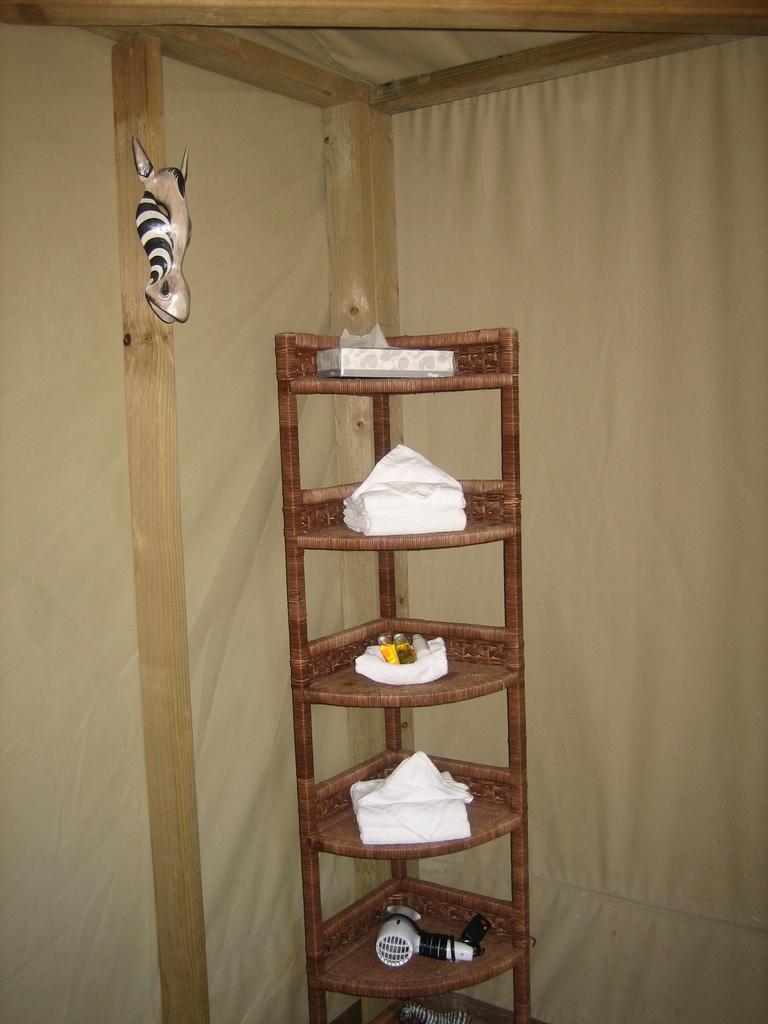Could you give a brief overview of what you see in this image? In this image we can see a box, tissue papers, bottles and a hair dryer which are placed in the racks. We can also see a decor on a wooden pole and a curtain. 